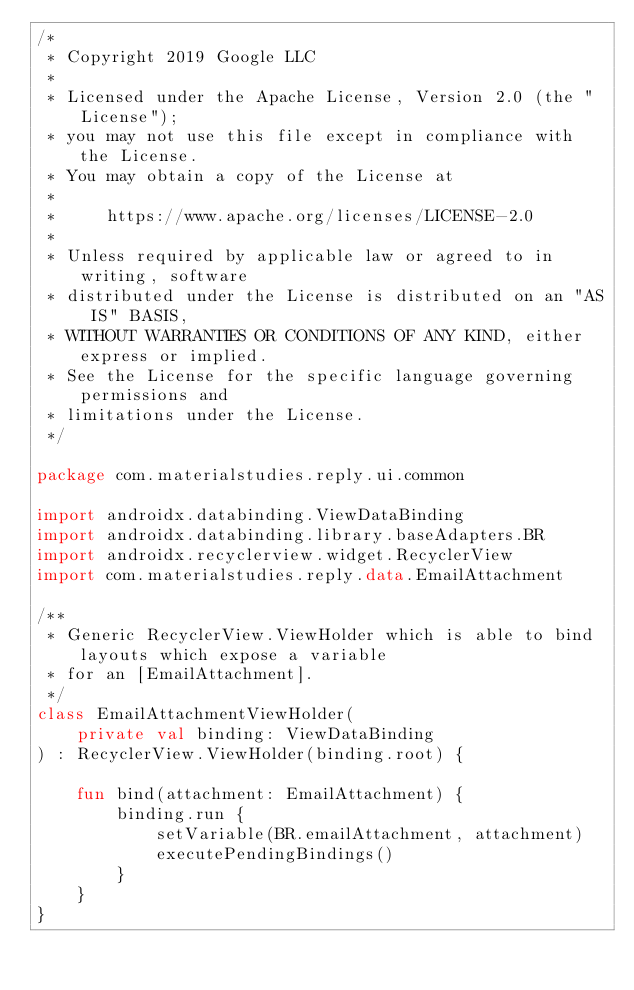<code> <loc_0><loc_0><loc_500><loc_500><_Kotlin_>/*
 * Copyright 2019 Google LLC
 *
 * Licensed under the Apache License, Version 2.0 (the "License");
 * you may not use this file except in compliance with the License.
 * You may obtain a copy of the License at
 *
 *     https://www.apache.org/licenses/LICENSE-2.0
 *
 * Unless required by applicable law or agreed to in writing, software
 * distributed under the License is distributed on an "AS IS" BASIS,
 * WITHOUT WARRANTIES OR CONDITIONS OF ANY KIND, either express or implied.
 * See the License for the specific language governing permissions and
 * limitations under the License.
 */

package com.materialstudies.reply.ui.common

import androidx.databinding.ViewDataBinding
import androidx.databinding.library.baseAdapters.BR
import androidx.recyclerview.widget.RecyclerView
import com.materialstudies.reply.data.EmailAttachment

/**
 * Generic RecyclerView.ViewHolder which is able to bind layouts which expose a variable
 * for an [EmailAttachment].
 */
class EmailAttachmentViewHolder(
    private val binding: ViewDataBinding
) : RecyclerView.ViewHolder(binding.root) {

    fun bind(attachment: EmailAttachment) {
        binding.run {
            setVariable(BR.emailAttachment, attachment)
            executePendingBindings()
        }
    }
}</code> 